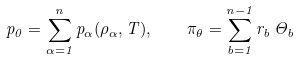<formula> <loc_0><loc_0><loc_500><loc_500>p _ { 0 } = \sum _ { \alpha = 1 } ^ { n } p _ { \alpha } ( \rho _ { \alpha } , T ) , \quad \pi _ { \theta } = \sum _ { b = 1 } ^ { n - 1 } r _ { b } \, \Theta _ { b }</formula> 